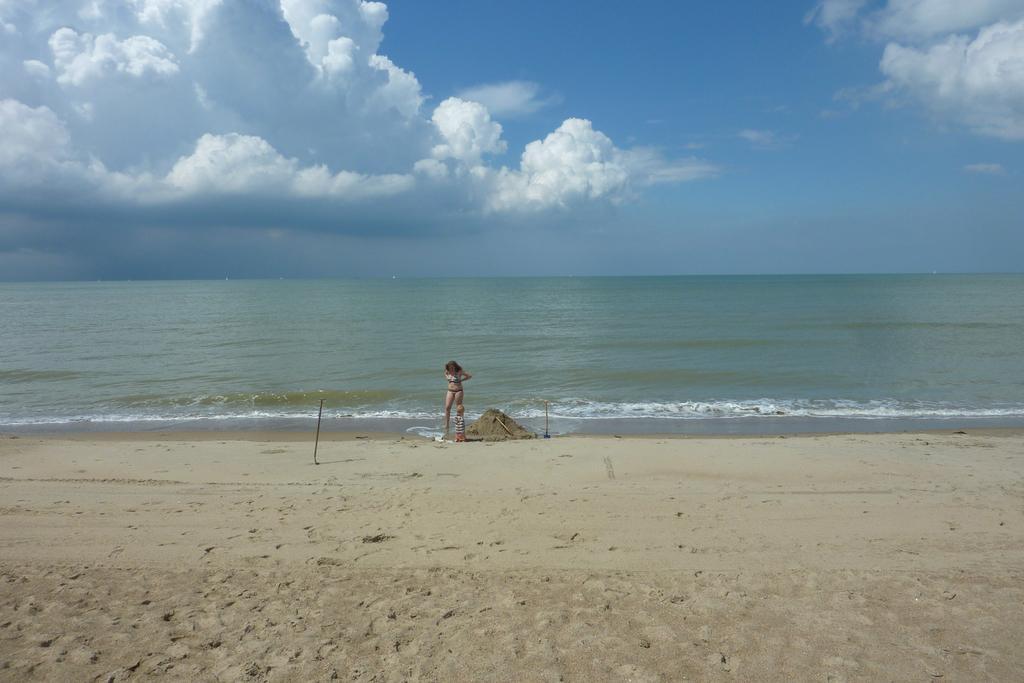Describe this image in one or two sentences. In the center of the image we can see a lady standing. In the background there is water. At the bottom there is sand. In the background there is sky. 